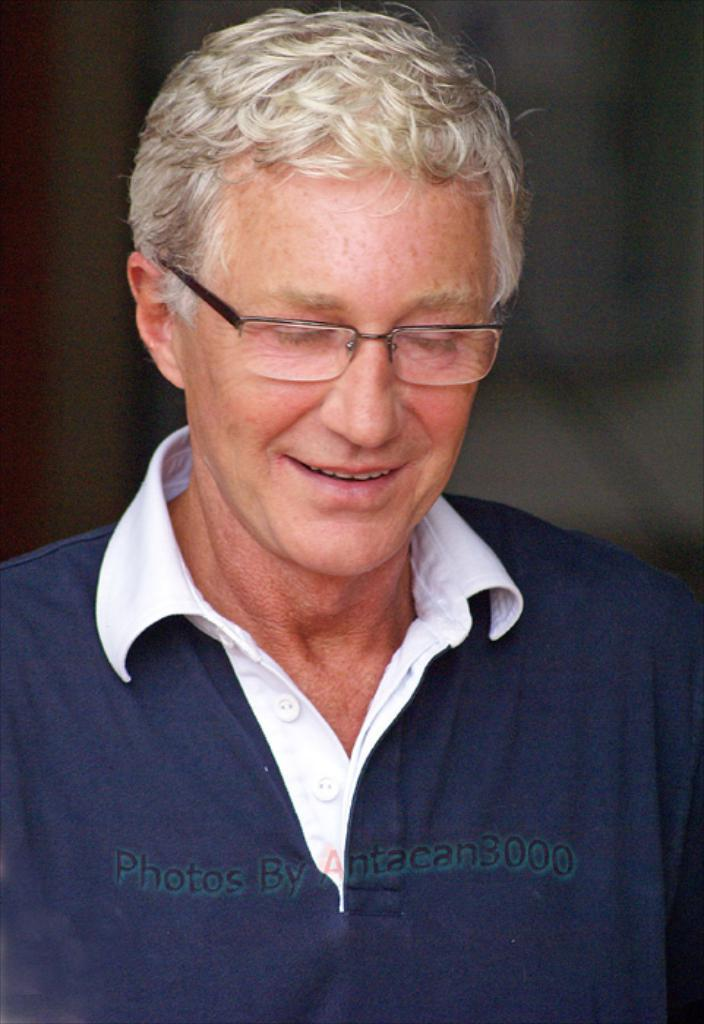Who or what is the main subject in the image? There is a person in the image. What is the person wearing in the image? The person is wearing a blue and white color shirt. Can you describe the background of the image? The background of the image is dark. What type of polish is the person applying to their nails in the image? There is no indication in the image that the person is applying polish to their nails, as the focus is on the person's shirt and the dark background. 